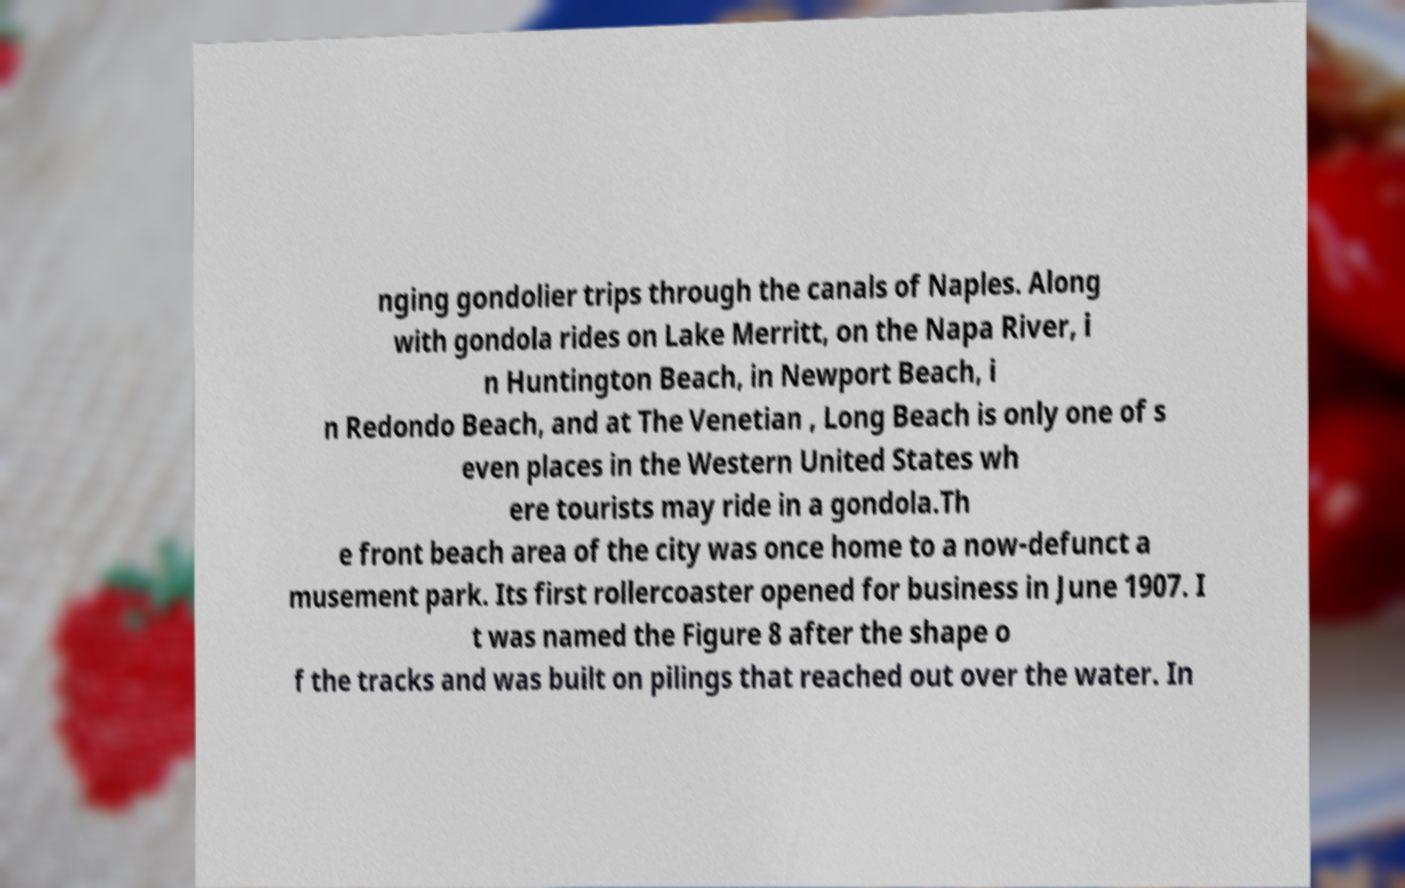Please identify and transcribe the text found in this image. nging gondolier trips through the canals of Naples. Along with gondola rides on Lake Merritt, on the Napa River, i n Huntington Beach, in Newport Beach, i n Redondo Beach, and at The Venetian , Long Beach is only one of s even places in the Western United States wh ere tourists may ride in a gondola.Th e front beach area of the city was once home to a now-defunct a musement park. Its first rollercoaster opened for business in June 1907. I t was named the Figure 8 after the shape o f the tracks and was built on pilings that reached out over the water. In 